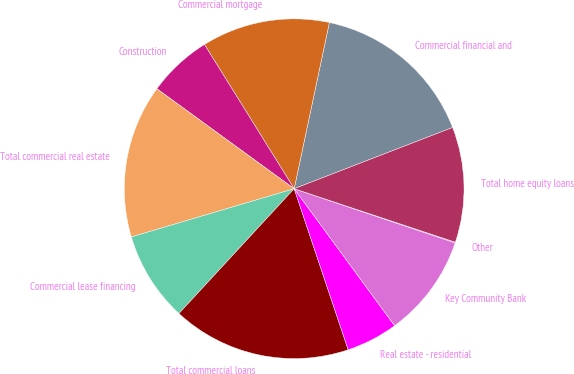Convert chart. <chart><loc_0><loc_0><loc_500><loc_500><pie_chart><fcel>Commercial financial and<fcel>Commercial mortgage<fcel>Construction<fcel>Total commercial real estate<fcel>Commercial lease financing<fcel>Total commercial loans<fcel>Real estate - residential<fcel>Key Community Bank<fcel>Other<fcel>Total home equity loans<nl><fcel>15.81%<fcel>12.18%<fcel>6.13%<fcel>14.6%<fcel>8.55%<fcel>17.02%<fcel>4.92%<fcel>9.76%<fcel>0.07%<fcel>10.97%<nl></chart> 